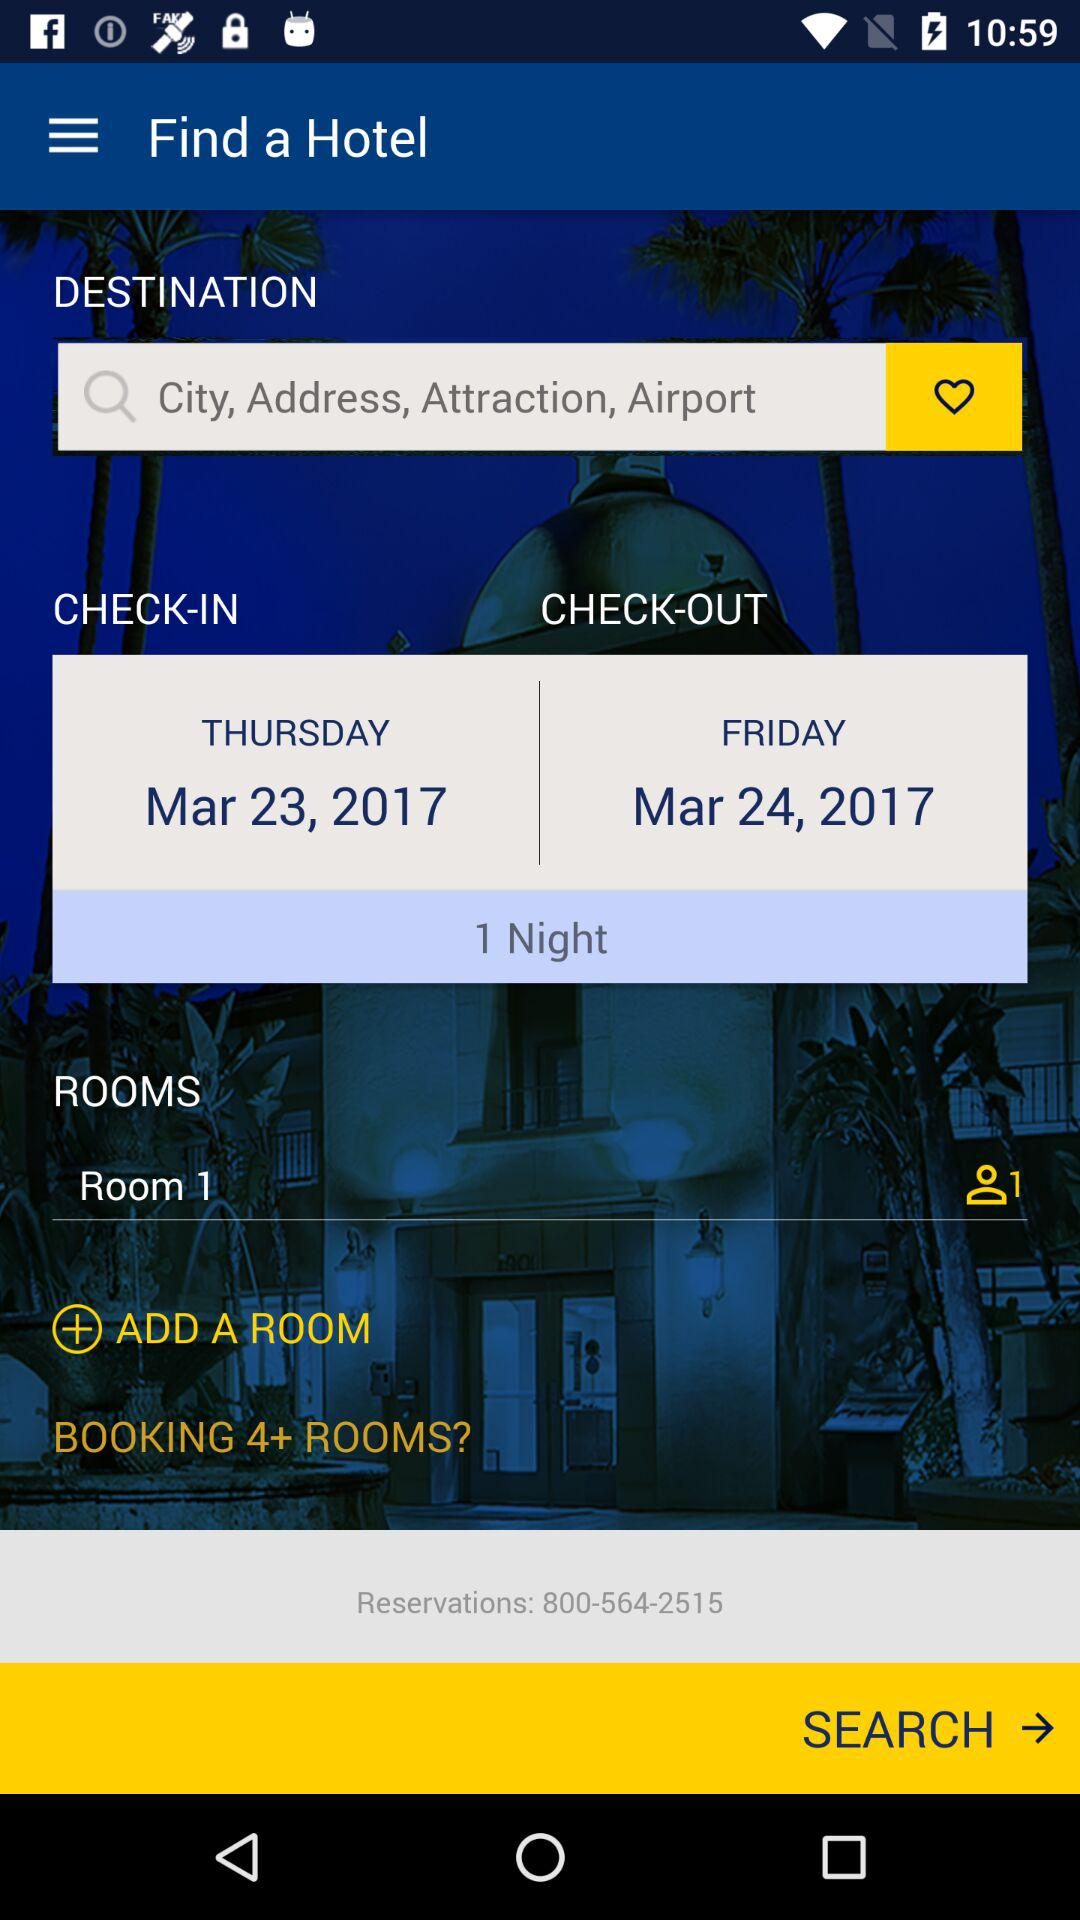What is the reservation number? The reservation number is 800-564-2515. 